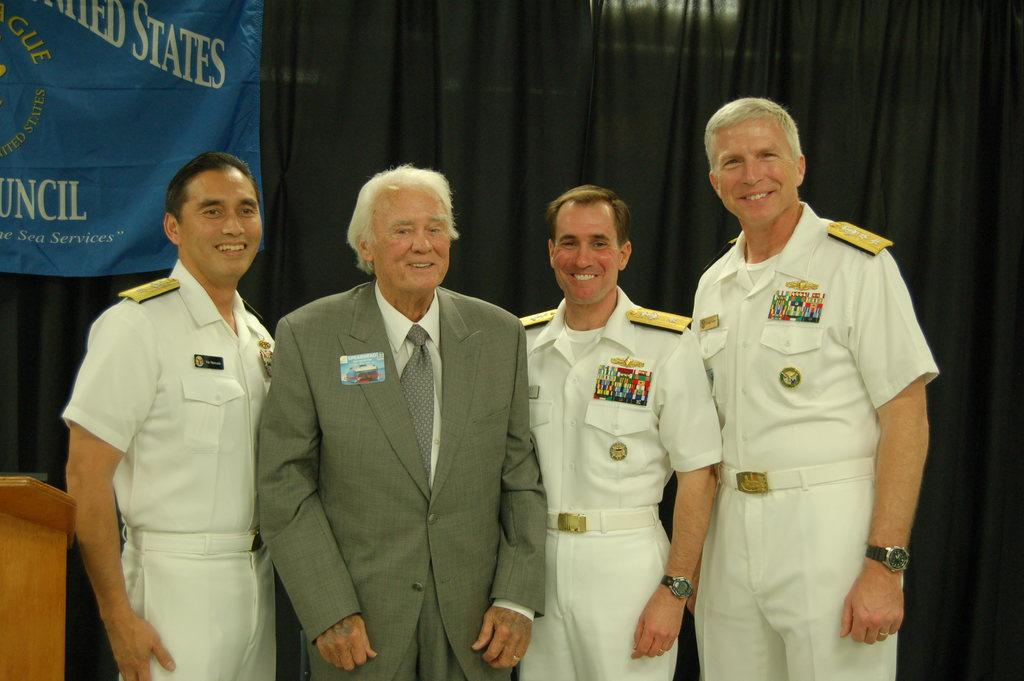<image>
Write a terse but informative summary of the picture. Four men pose for a photo in front of a blue banner that has the word "states" on it. 